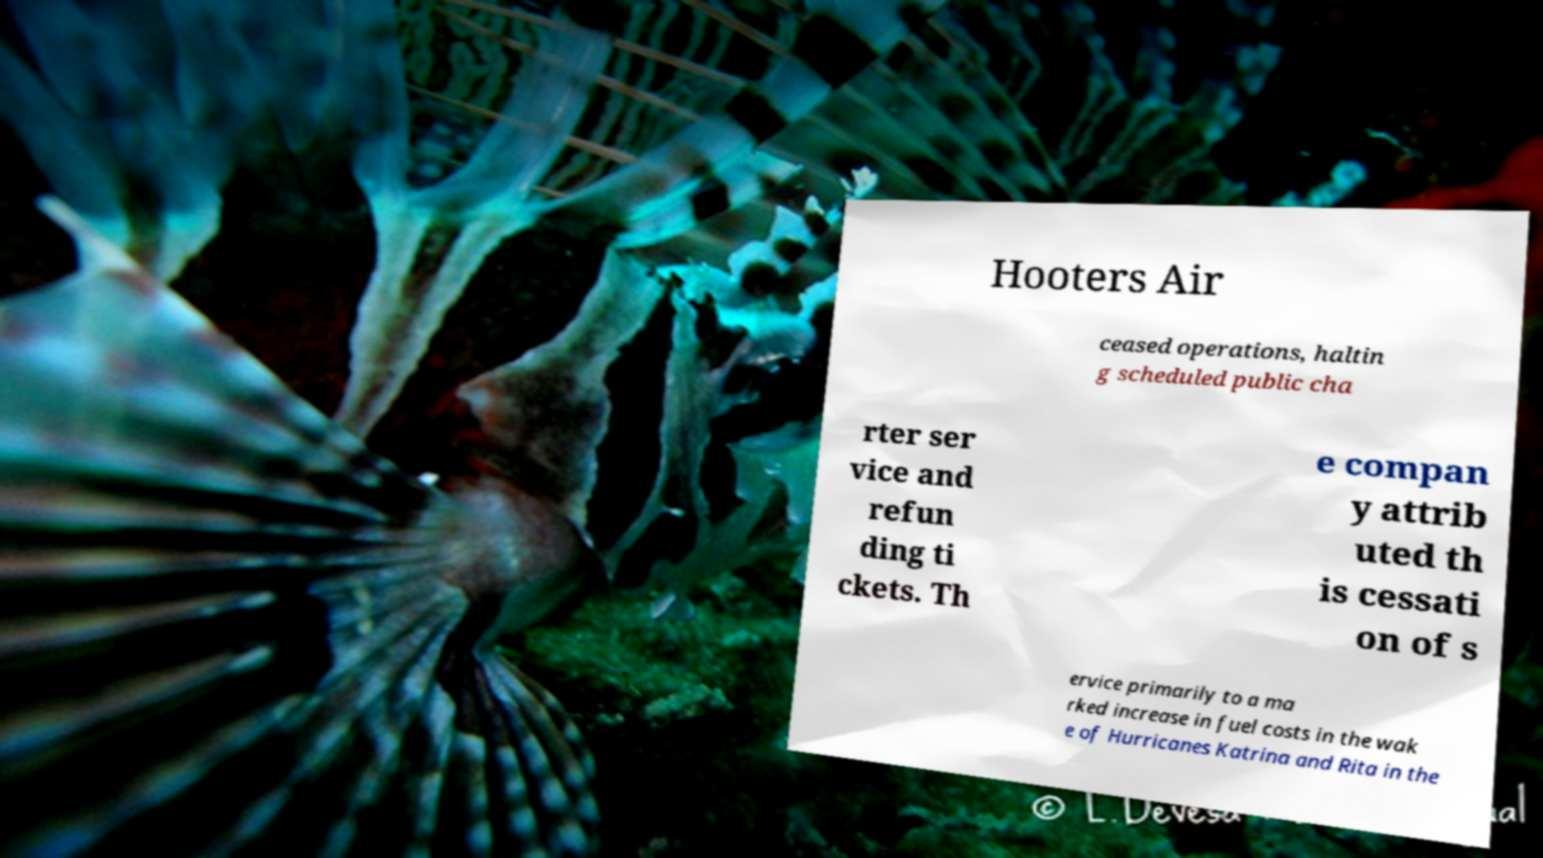There's text embedded in this image that I need extracted. Can you transcribe it verbatim? Hooters Air ceased operations, haltin g scheduled public cha rter ser vice and refun ding ti ckets. Th e compan y attrib uted th is cessati on of s ervice primarily to a ma rked increase in fuel costs in the wak e of Hurricanes Katrina and Rita in the 